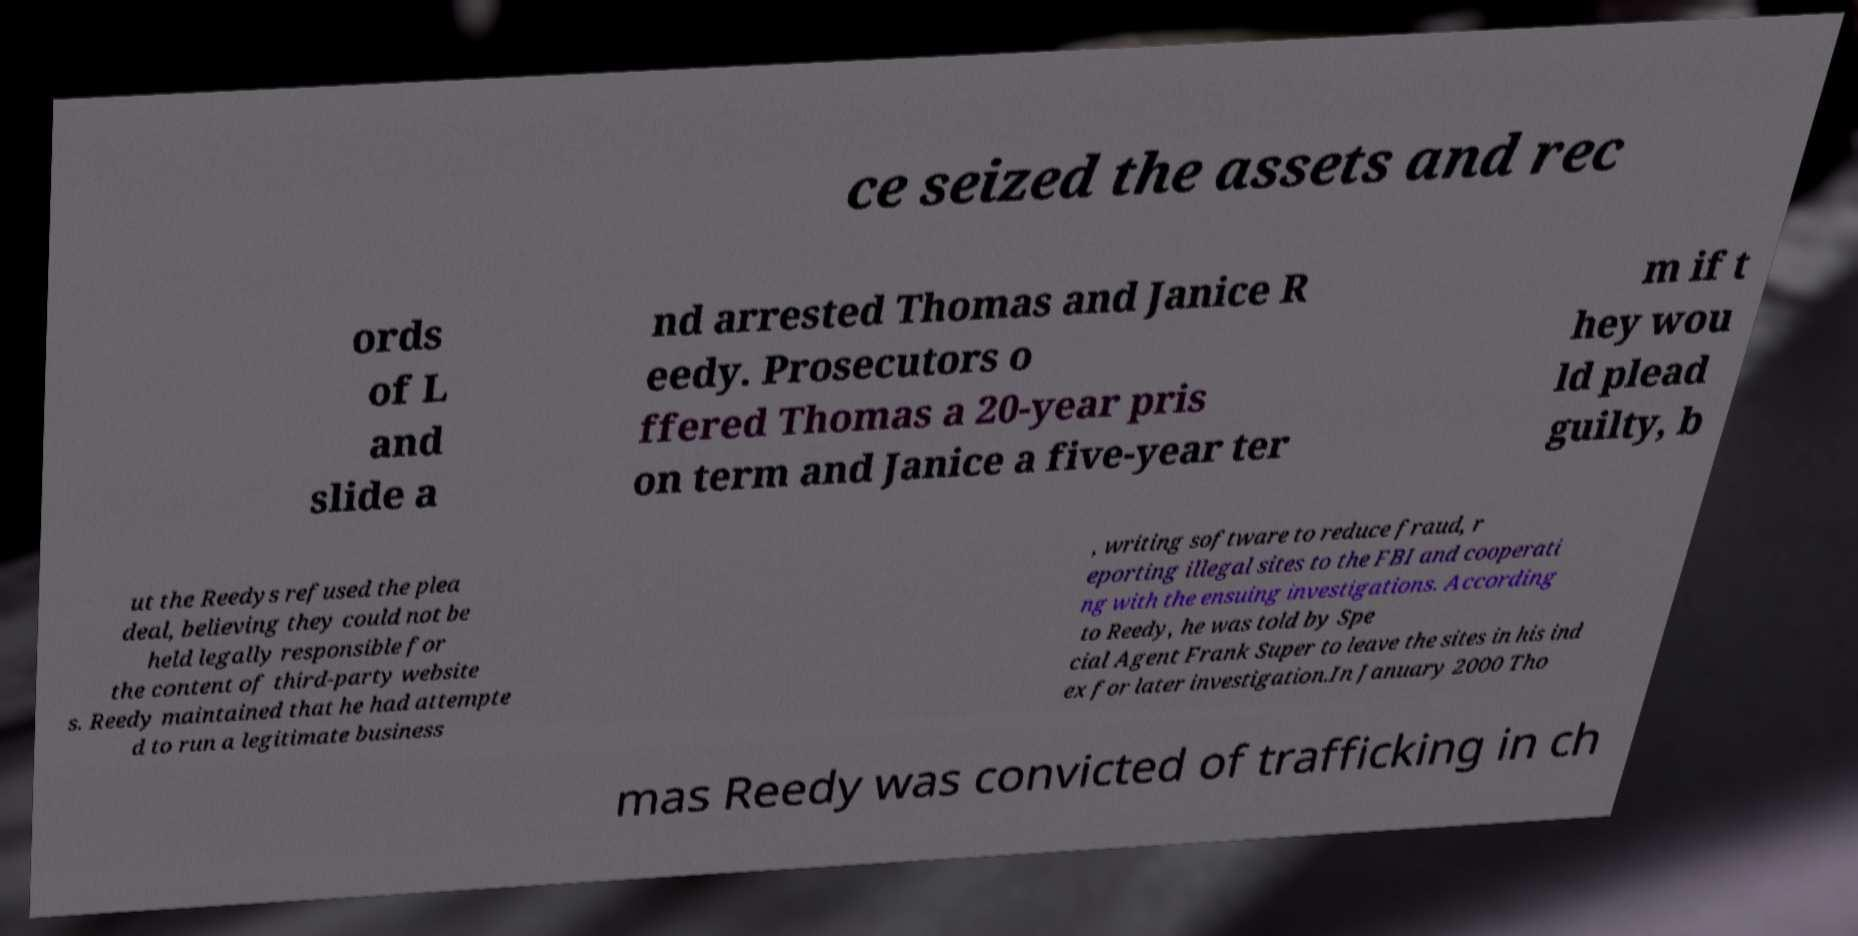Can you accurately transcribe the text from the provided image for me? ce seized the assets and rec ords of L and slide a nd arrested Thomas and Janice R eedy. Prosecutors o ffered Thomas a 20-year pris on term and Janice a five-year ter m if t hey wou ld plead guilty, b ut the Reedys refused the plea deal, believing they could not be held legally responsible for the content of third-party website s. Reedy maintained that he had attempte d to run a legitimate business , writing software to reduce fraud, r eporting illegal sites to the FBI and cooperati ng with the ensuing investigations. According to Reedy, he was told by Spe cial Agent Frank Super to leave the sites in his ind ex for later investigation.In January 2000 Tho mas Reedy was convicted of trafficking in ch 